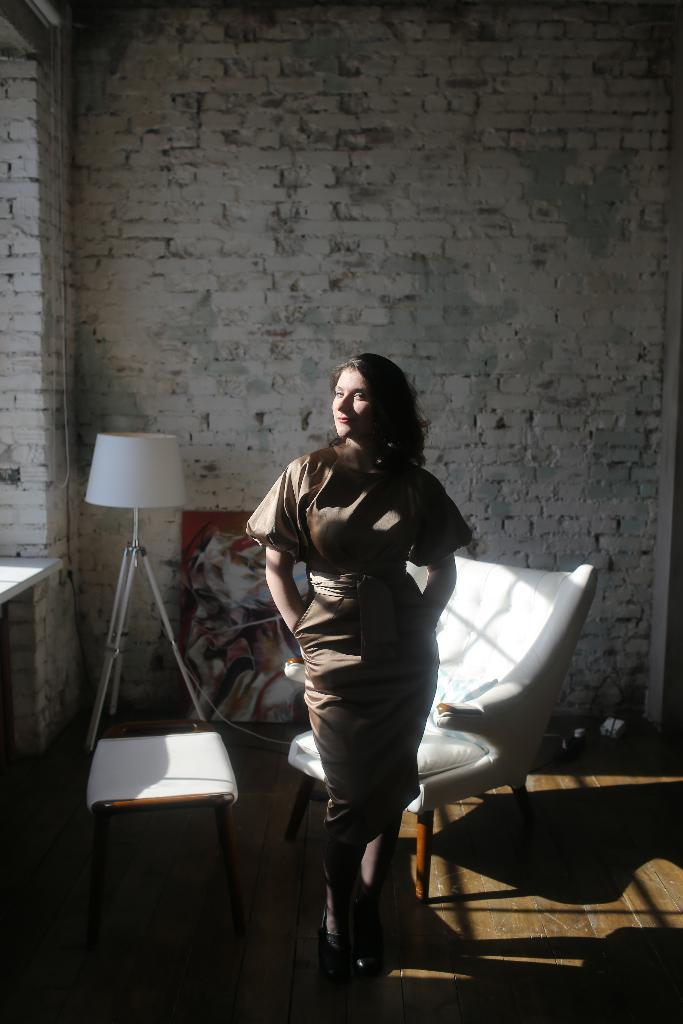What is the main subject of the image? There is a woman standing in the image. Where is the woman standing? The woman is standing on the floor. What objects can be seen in the background of the image? There is a coffee table, a chair, a lamp, and a painting in the background of the image. What type of surface is visible in the image? There is a wall visible in the image. What type of treatment is the woman receiving in the image? There is no indication in the image that the woman is receiving any treatment. Can you see a chessboard in the image? There is no chessboard present in the image. 